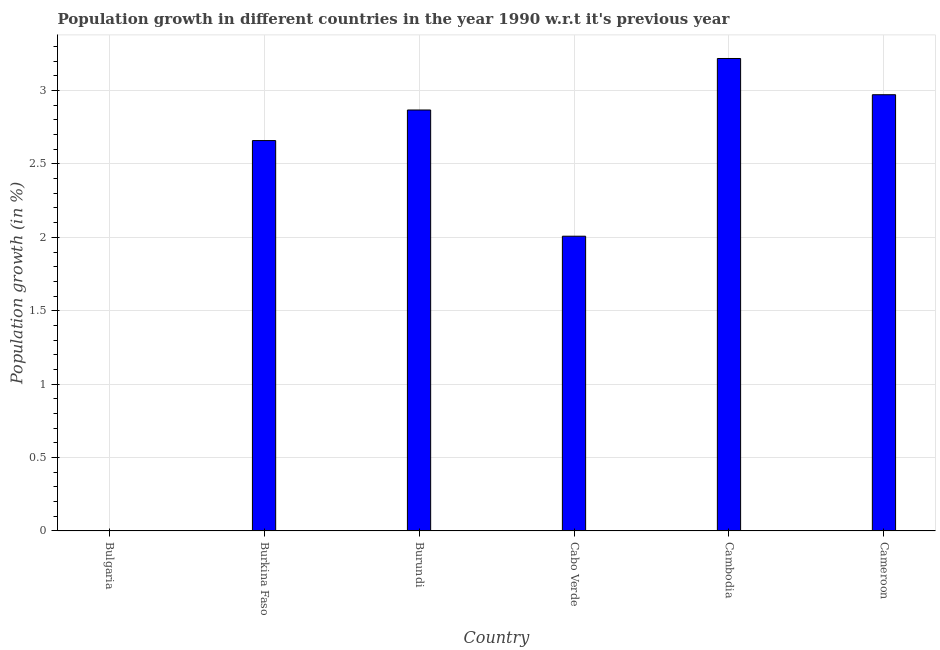What is the title of the graph?
Provide a succinct answer. Population growth in different countries in the year 1990 w.r.t it's previous year. What is the label or title of the X-axis?
Keep it short and to the point. Country. What is the label or title of the Y-axis?
Provide a short and direct response. Population growth (in %). What is the population growth in Burkina Faso?
Provide a succinct answer. 2.66. Across all countries, what is the maximum population growth?
Keep it short and to the point. 3.22. In which country was the population growth maximum?
Provide a succinct answer. Cambodia. What is the sum of the population growth?
Ensure brevity in your answer.  13.72. What is the difference between the population growth in Burkina Faso and Cambodia?
Offer a terse response. -0.56. What is the average population growth per country?
Give a very brief answer. 2.29. What is the median population growth?
Offer a very short reply. 2.76. What is the ratio of the population growth in Burundi to that in Cabo Verde?
Your answer should be very brief. 1.43. What is the difference between the highest and the second highest population growth?
Ensure brevity in your answer.  0.25. Is the sum of the population growth in Cambodia and Cameroon greater than the maximum population growth across all countries?
Ensure brevity in your answer.  Yes. What is the difference between the highest and the lowest population growth?
Your answer should be compact. 3.22. In how many countries, is the population growth greater than the average population growth taken over all countries?
Keep it short and to the point. 4. Are all the bars in the graph horizontal?
Your response must be concise. No. Are the values on the major ticks of Y-axis written in scientific E-notation?
Provide a short and direct response. No. What is the Population growth (in %) of Bulgaria?
Provide a short and direct response. 0. What is the Population growth (in %) of Burkina Faso?
Your response must be concise. 2.66. What is the Population growth (in %) in Burundi?
Offer a very short reply. 2.87. What is the Population growth (in %) of Cabo Verde?
Your answer should be compact. 2.01. What is the Population growth (in %) in Cambodia?
Your response must be concise. 3.22. What is the Population growth (in %) of Cameroon?
Your answer should be compact. 2.97. What is the difference between the Population growth (in %) in Burkina Faso and Burundi?
Your answer should be very brief. -0.21. What is the difference between the Population growth (in %) in Burkina Faso and Cabo Verde?
Keep it short and to the point. 0.65. What is the difference between the Population growth (in %) in Burkina Faso and Cambodia?
Give a very brief answer. -0.56. What is the difference between the Population growth (in %) in Burkina Faso and Cameroon?
Your response must be concise. -0.31. What is the difference between the Population growth (in %) in Burundi and Cabo Verde?
Your answer should be very brief. 0.86. What is the difference between the Population growth (in %) in Burundi and Cambodia?
Make the answer very short. -0.35. What is the difference between the Population growth (in %) in Burundi and Cameroon?
Give a very brief answer. -0.1. What is the difference between the Population growth (in %) in Cabo Verde and Cambodia?
Your answer should be compact. -1.21. What is the difference between the Population growth (in %) in Cabo Verde and Cameroon?
Make the answer very short. -0.96. What is the difference between the Population growth (in %) in Cambodia and Cameroon?
Offer a terse response. 0.25. What is the ratio of the Population growth (in %) in Burkina Faso to that in Burundi?
Offer a very short reply. 0.93. What is the ratio of the Population growth (in %) in Burkina Faso to that in Cabo Verde?
Make the answer very short. 1.32. What is the ratio of the Population growth (in %) in Burkina Faso to that in Cambodia?
Your answer should be very brief. 0.83. What is the ratio of the Population growth (in %) in Burkina Faso to that in Cameroon?
Your response must be concise. 0.9. What is the ratio of the Population growth (in %) in Burundi to that in Cabo Verde?
Offer a very short reply. 1.43. What is the ratio of the Population growth (in %) in Burundi to that in Cambodia?
Give a very brief answer. 0.89. What is the ratio of the Population growth (in %) in Cabo Verde to that in Cambodia?
Make the answer very short. 0.62. What is the ratio of the Population growth (in %) in Cabo Verde to that in Cameroon?
Offer a terse response. 0.68. What is the ratio of the Population growth (in %) in Cambodia to that in Cameroon?
Keep it short and to the point. 1.08. 